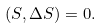Convert formula to latex. <formula><loc_0><loc_0><loc_500><loc_500>( S , \Delta S ) = 0 .</formula> 